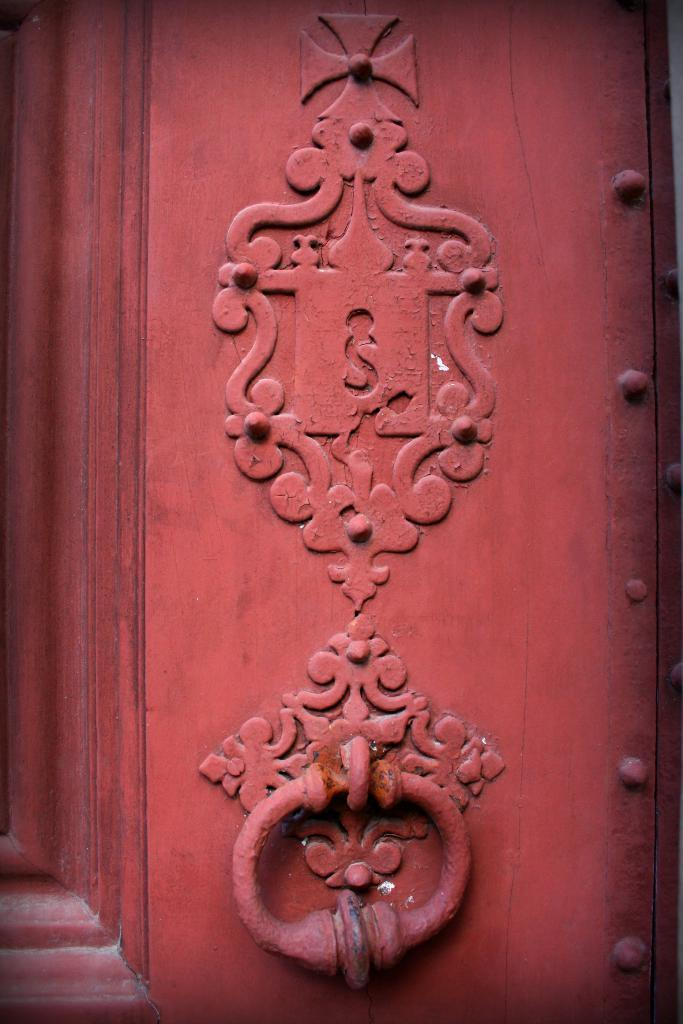What is present in the image that allows people to enter or exit a space? There is a door in the image. What feature is present on the door for people to use when knocking? The door has a knocker. What can be seen on the door that adds visual interest or decoration? There is some design on the door. How many low things can be seen on the door in the image? There is no mention of "low things" in the image, so it cannot be determined how many there are. 